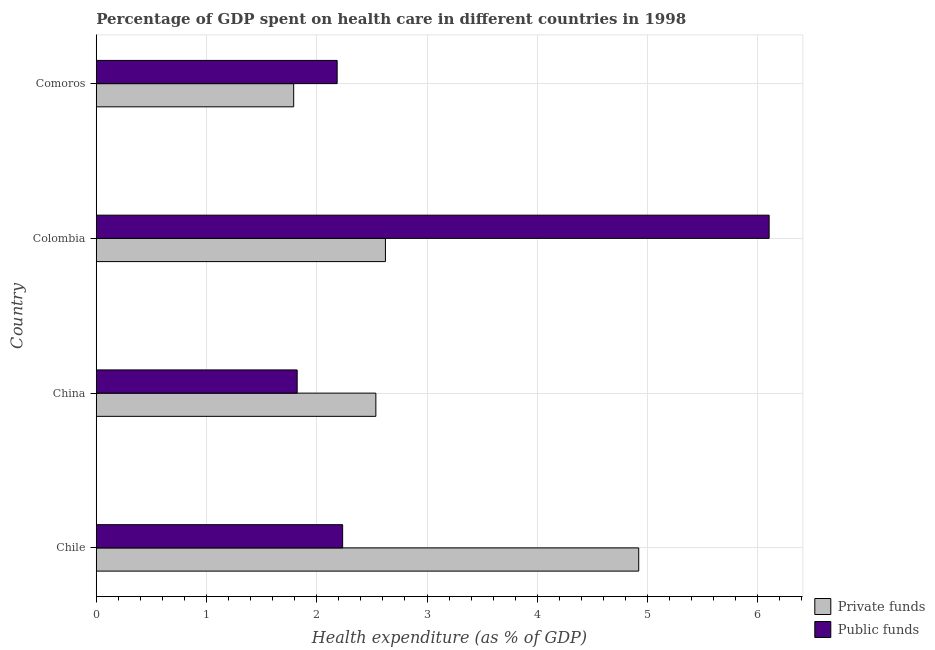How many groups of bars are there?
Your response must be concise. 4. Are the number of bars per tick equal to the number of legend labels?
Your answer should be very brief. Yes. How many bars are there on the 2nd tick from the top?
Your answer should be very brief. 2. What is the label of the 1st group of bars from the top?
Offer a terse response. Comoros. What is the amount of public funds spent in healthcare in China?
Offer a terse response. 1.82. Across all countries, what is the maximum amount of public funds spent in healthcare?
Offer a very short reply. 6.1. Across all countries, what is the minimum amount of public funds spent in healthcare?
Provide a short and direct response. 1.82. In which country was the amount of public funds spent in healthcare minimum?
Provide a short and direct response. China. What is the total amount of private funds spent in healthcare in the graph?
Your response must be concise. 11.87. What is the difference between the amount of public funds spent in healthcare in Chile and that in Comoros?
Provide a short and direct response. 0.05. What is the difference between the amount of private funds spent in healthcare in Colombia and the amount of public funds spent in healthcare in Comoros?
Offer a very short reply. 0.44. What is the average amount of private funds spent in healthcare per country?
Ensure brevity in your answer.  2.97. What is the difference between the amount of public funds spent in healthcare and amount of private funds spent in healthcare in China?
Provide a succinct answer. -0.71. What is the ratio of the amount of public funds spent in healthcare in China to that in Colombia?
Offer a terse response. 0.3. Is the amount of public funds spent in healthcare in Chile less than that in China?
Provide a succinct answer. No. What is the difference between the highest and the second highest amount of public funds spent in healthcare?
Keep it short and to the point. 3.87. What is the difference between the highest and the lowest amount of private funds spent in healthcare?
Provide a succinct answer. 3.13. In how many countries, is the amount of public funds spent in healthcare greater than the average amount of public funds spent in healthcare taken over all countries?
Your answer should be very brief. 1. What does the 1st bar from the top in Comoros represents?
Make the answer very short. Public funds. What does the 1st bar from the bottom in Colombia represents?
Provide a short and direct response. Private funds. How many bars are there?
Your response must be concise. 8. How many countries are there in the graph?
Offer a terse response. 4. What is the difference between two consecutive major ticks on the X-axis?
Give a very brief answer. 1. Does the graph contain any zero values?
Your answer should be compact. No. Does the graph contain grids?
Offer a terse response. Yes. Where does the legend appear in the graph?
Your answer should be very brief. Bottom right. What is the title of the graph?
Offer a terse response. Percentage of GDP spent on health care in different countries in 1998. What is the label or title of the X-axis?
Offer a terse response. Health expenditure (as % of GDP). What is the label or title of the Y-axis?
Offer a terse response. Country. What is the Health expenditure (as % of GDP) in Private funds in Chile?
Provide a succinct answer. 4.92. What is the Health expenditure (as % of GDP) of Public funds in Chile?
Keep it short and to the point. 2.23. What is the Health expenditure (as % of GDP) of Private funds in China?
Provide a short and direct response. 2.54. What is the Health expenditure (as % of GDP) in Public funds in China?
Your answer should be compact. 1.82. What is the Health expenditure (as % of GDP) in Private funds in Colombia?
Your response must be concise. 2.62. What is the Health expenditure (as % of GDP) in Public funds in Colombia?
Make the answer very short. 6.1. What is the Health expenditure (as % of GDP) in Private funds in Comoros?
Keep it short and to the point. 1.79. What is the Health expenditure (as % of GDP) of Public funds in Comoros?
Your answer should be compact. 2.19. Across all countries, what is the maximum Health expenditure (as % of GDP) of Private funds?
Provide a short and direct response. 4.92. Across all countries, what is the maximum Health expenditure (as % of GDP) of Public funds?
Give a very brief answer. 6.1. Across all countries, what is the minimum Health expenditure (as % of GDP) in Private funds?
Keep it short and to the point. 1.79. Across all countries, what is the minimum Health expenditure (as % of GDP) of Public funds?
Make the answer very short. 1.82. What is the total Health expenditure (as % of GDP) in Private funds in the graph?
Provide a succinct answer. 11.87. What is the total Health expenditure (as % of GDP) of Public funds in the graph?
Offer a very short reply. 12.35. What is the difference between the Health expenditure (as % of GDP) of Private funds in Chile and that in China?
Provide a short and direct response. 2.38. What is the difference between the Health expenditure (as % of GDP) of Public funds in Chile and that in China?
Provide a succinct answer. 0.41. What is the difference between the Health expenditure (as % of GDP) of Private funds in Chile and that in Colombia?
Give a very brief answer. 2.3. What is the difference between the Health expenditure (as % of GDP) of Public funds in Chile and that in Colombia?
Keep it short and to the point. -3.87. What is the difference between the Health expenditure (as % of GDP) of Private funds in Chile and that in Comoros?
Keep it short and to the point. 3.13. What is the difference between the Health expenditure (as % of GDP) in Public funds in Chile and that in Comoros?
Provide a succinct answer. 0.05. What is the difference between the Health expenditure (as % of GDP) of Private funds in China and that in Colombia?
Your response must be concise. -0.09. What is the difference between the Health expenditure (as % of GDP) of Public funds in China and that in Colombia?
Your answer should be compact. -4.28. What is the difference between the Health expenditure (as % of GDP) of Private funds in China and that in Comoros?
Your answer should be very brief. 0.75. What is the difference between the Health expenditure (as % of GDP) in Public funds in China and that in Comoros?
Your answer should be compact. -0.36. What is the difference between the Health expenditure (as % of GDP) in Private funds in Colombia and that in Comoros?
Your response must be concise. 0.83. What is the difference between the Health expenditure (as % of GDP) in Public funds in Colombia and that in Comoros?
Make the answer very short. 3.92. What is the difference between the Health expenditure (as % of GDP) in Private funds in Chile and the Health expenditure (as % of GDP) in Public funds in China?
Offer a very short reply. 3.1. What is the difference between the Health expenditure (as % of GDP) in Private funds in Chile and the Health expenditure (as % of GDP) in Public funds in Colombia?
Keep it short and to the point. -1.18. What is the difference between the Health expenditure (as % of GDP) in Private funds in Chile and the Health expenditure (as % of GDP) in Public funds in Comoros?
Offer a terse response. 2.74. What is the difference between the Health expenditure (as % of GDP) in Private funds in China and the Health expenditure (as % of GDP) in Public funds in Colombia?
Your answer should be compact. -3.57. What is the difference between the Health expenditure (as % of GDP) of Private funds in China and the Health expenditure (as % of GDP) of Public funds in Comoros?
Offer a very short reply. 0.35. What is the difference between the Health expenditure (as % of GDP) of Private funds in Colombia and the Health expenditure (as % of GDP) of Public funds in Comoros?
Keep it short and to the point. 0.44. What is the average Health expenditure (as % of GDP) in Private funds per country?
Your response must be concise. 2.97. What is the average Health expenditure (as % of GDP) in Public funds per country?
Your answer should be compact. 3.09. What is the difference between the Health expenditure (as % of GDP) of Private funds and Health expenditure (as % of GDP) of Public funds in Chile?
Your answer should be very brief. 2.69. What is the difference between the Health expenditure (as % of GDP) in Private funds and Health expenditure (as % of GDP) in Public funds in China?
Keep it short and to the point. 0.71. What is the difference between the Health expenditure (as % of GDP) in Private funds and Health expenditure (as % of GDP) in Public funds in Colombia?
Keep it short and to the point. -3.48. What is the difference between the Health expenditure (as % of GDP) in Private funds and Health expenditure (as % of GDP) in Public funds in Comoros?
Give a very brief answer. -0.39. What is the ratio of the Health expenditure (as % of GDP) of Private funds in Chile to that in China?
Offer a very short reply. 1.94. What is the ratio of the Health expenditure (as % of GDP) in Public funds in Chile to that in China?
Keep it short and to the point. 1.23. What is the ratio of the Health expenditure (as % of GDP) in Private funds in Chile to that in Colombia?
Offer a terse response. 1.88. What is the ratio of the Health expenditure (as % of GDP) of Public funds in Chile to that in Colombia?
Give a very brief answer. 0.37. What is the ratio of the Health expenditure (as % of GDP) in Private funds in Chile to that in Comoros?
Provide a succinct answer. 2.75. What is the ratio of the Health expenditure (as % of GDP) in Public funds in Chile to that in Comoros?
Offer a terse response. 1.02. What is the ratio of the Health expenditure (as % of GDP) in Private funds in China to that in Colombia?
Provide a succinct answer. 0.97. What is the ratio of the Health expenditure (as % of GDP) in Public funds in China to that in Colombia?
Ensure brevity in your answer.  0.3. What is the ratio of the Health expenditure (as % of GDP) of Private funds in China to that in Comoros?
Provide a succinct answer. 1.42. What is the ratio of the Health expenditure (as % of GDP) in Public funds in China to that in Comoros?
Your answer should be very brief. 0.83. What is the ratio of the Health expenditure (as % of GDP) of Private funds in Colombia to that in Comoros?
Provide a succinct answer. 1.46. What is the ratio of the Health expenditure (as % of GDP) of Public funds in Colombia to that in Comoros?
Make the answer very short. 2.79. What is the difference between the highest and the second highest Health expenditure (as % of GDP) of Private funds?
Your answer should be very brief. 2.3. What is the difference between the highest and the second highest Health expenditure (as % of GDP) in Public funds?
Make the answer very short. 3.87. What is the difference between the highest and the lowest Health expenditure (as % of GDP) in Private funds?
Provide a succinct answer. 3.13. What is the difference between the highest and the lowest Health expenditure (as % of GDP) in Public funds?
Provide a short and direct response. 4.28. 